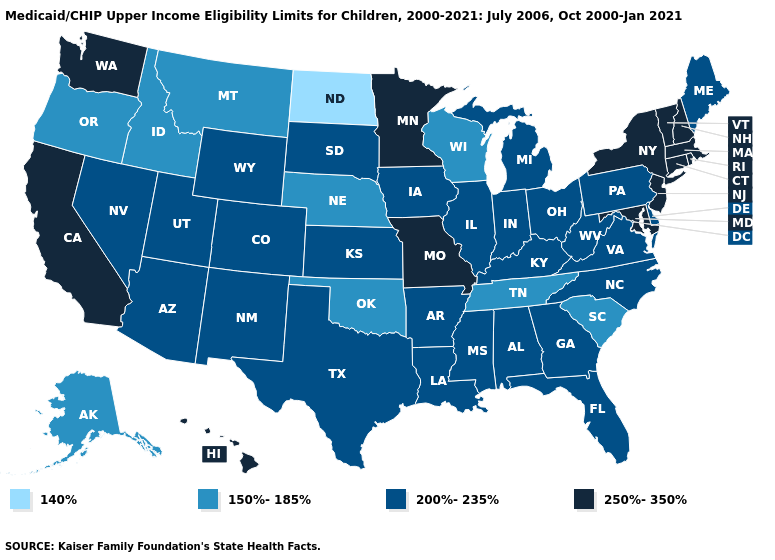Does the first symbol in the legend represent the smallest category?
Short answer required. Yes. Does the map have missing data?
Give a very brief answer. No. What is the highest value in states that border Oklahoma?
Quick response, please. 250%-350%. Name the states that have a value in the range 250%-350%?
Be succinct. California, Connecticut, Hawaii, Maryland, Massachusetts, Minnesota, Missouri, New Hampshire, New Jersey, New York, Rhode Island, Vermont, Washington. Name the states that have a value in the range 250%-350%?
Quick response, please. California, Connecticut, Hawaii, Maryland, Massachusetts, Minnesota, Missouri, New Hampshire, New Jersey, New York, Rhode Island, Vermont, Washington. What is the highest value in states that border Ohio?
Concise answer only. 200%-235%. Name the states that have a value in the range 200%-235%?
Be succinct. Alabama, Arizona, Arkansas, Colorado, Delaware, Florida, Georgia, Illinois, Indiana, Iowa, Kansas, Kentucky, Louisiana, Maine, Michigan, Mississippi, Nevada, New Mexico, North Carolina, Ohio, Pennsylvania, South Dakota, Texas, Utah, Virginia, West Virginia, Wyoming. Name the states that have a value in the range 140%?
Be succinct. North Dakota. Among the states that border Oregon , which have the highest value?
Write a very short answer. California, Washington. What is the value of Rhode Island?
Keep it brief. 250%-350%. Does South Dakota have the highest value in the USA?
Give a very brief answer. No. Does the first symbol in the legend represent the smallest category?
Keep it brief. Yes. What is the lowest value in the Northeast?
Write a very short answer. 200%-235%. Name the states that have a value in the range 200%-235%?
Keep it brief. Alabama, Arizona, Arkansas, Colorado, Delaware, Florida, Georgia, Illinois, Indiana, Iowa, Kansas, Kentucky, Louisiana, Maine, Michigan, Mississippi, Nevada, New Mexico, North Carolina, Ohio, Pennsylvania, South Dakota, Texas, Utah, Virginia, West Virginia, Wyoming. 